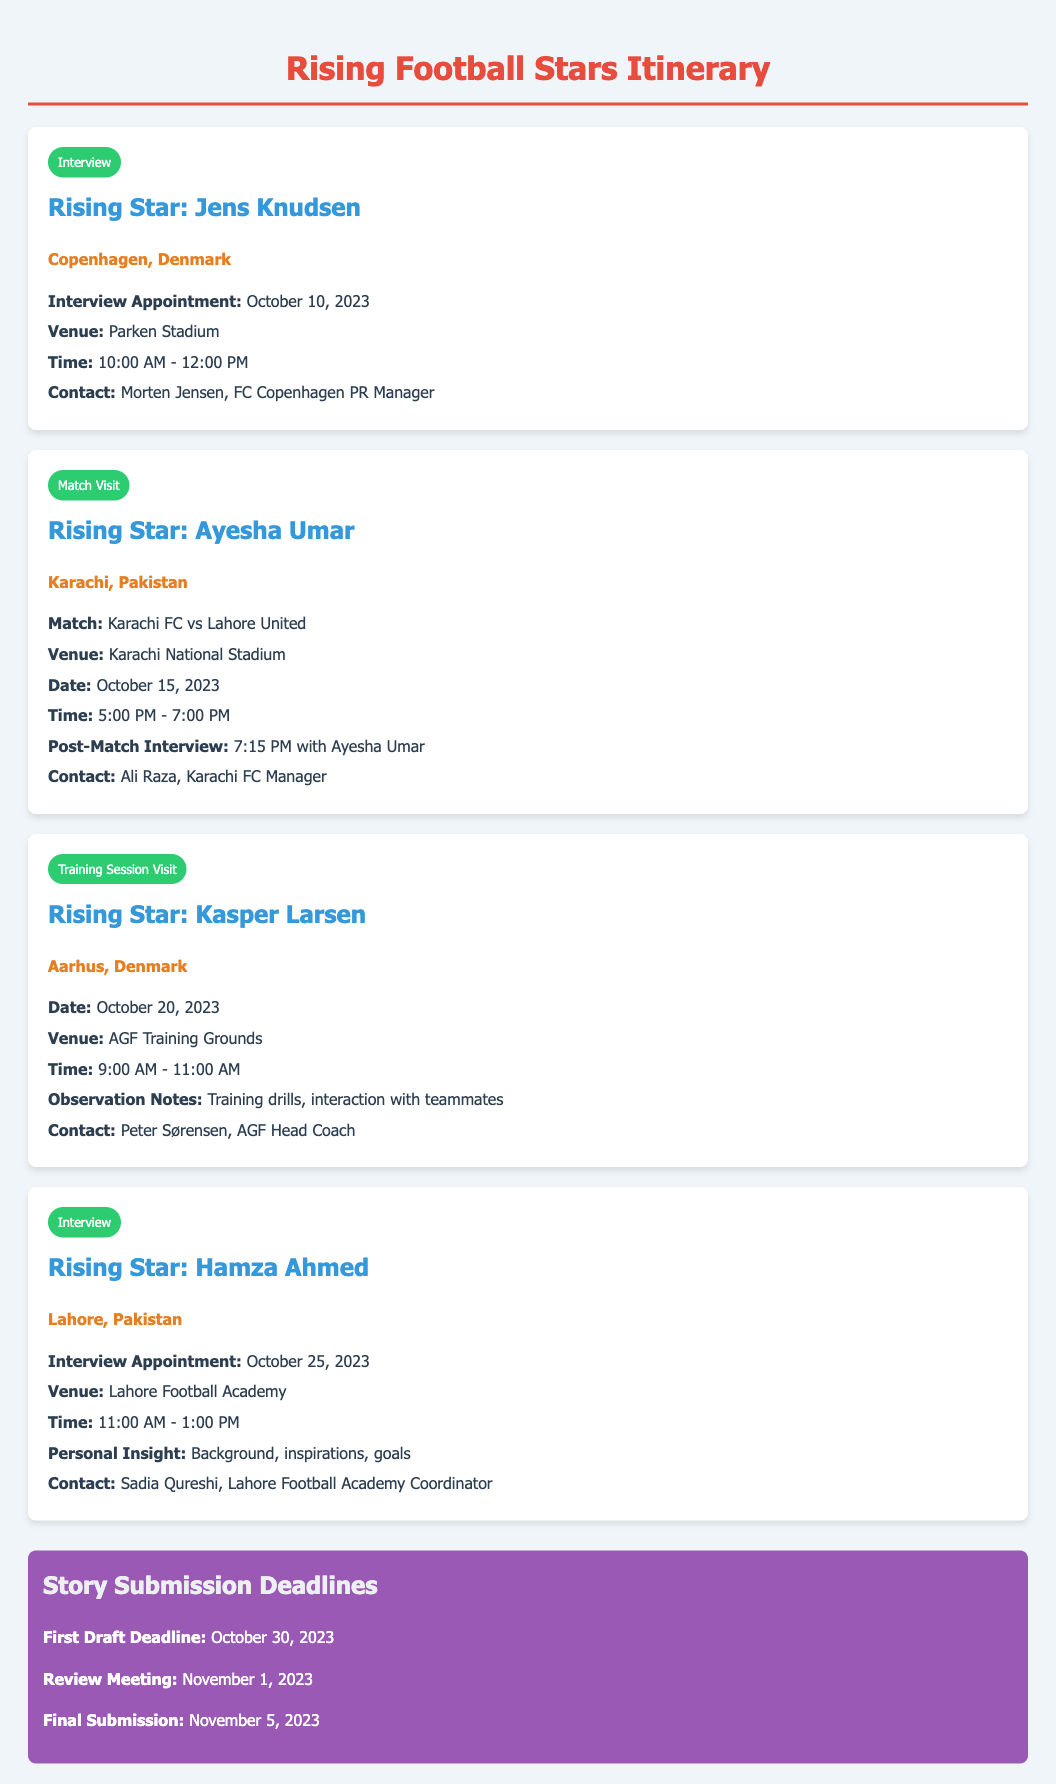What is the name of the rising star in Copenhagen? The name of the rising star in Copenhagen mentioned in the itinerary is Jens Knudsen.
Answer: Jens Knudsen When is the interview appointment for Hamza Ahmed? The interview appointment for Hamza Ahmed is scheduled for October 25, 2023.
Answer: October 25, 2023 What is the venue for the match between Karachi FC and Lahore United? The venue for the match between Karachi FC and Lahore United is Karachi National Stadium.
Answer: Karachi National Stadium What time does the training session visit for Kasper Larsen begin? The training session visit for Kasper Larsen begins at 9:00 AM.
Answer: 9:00 AM What is the first draft deadline for story submissions? The first draft deadline for story submissions is October 30, 2023.
Answer: October 30, 2023 Who is the contact for the interview with Ayesha Umar? The contact for the interview with Ayesha Umar is Ali Raza.
Answer: Ali Raza Where will the interview with Jens Knudsen take place? The interview with Jens Knudsen will take place at Parken Stadium.
Answer: Parken Stadium What date is the training session visit scheduled for? The training session visit for Kasper Larsen is scheduled for October 20, 2023.
Answer: October 20, 2023 What personal insight will be covered in the interview with Hamza Ahmed? The personal insight that will be covered in the interview with Hamza Ahmed includes background, inspirations, and goals.
Answer: Background, inspirations, goals 